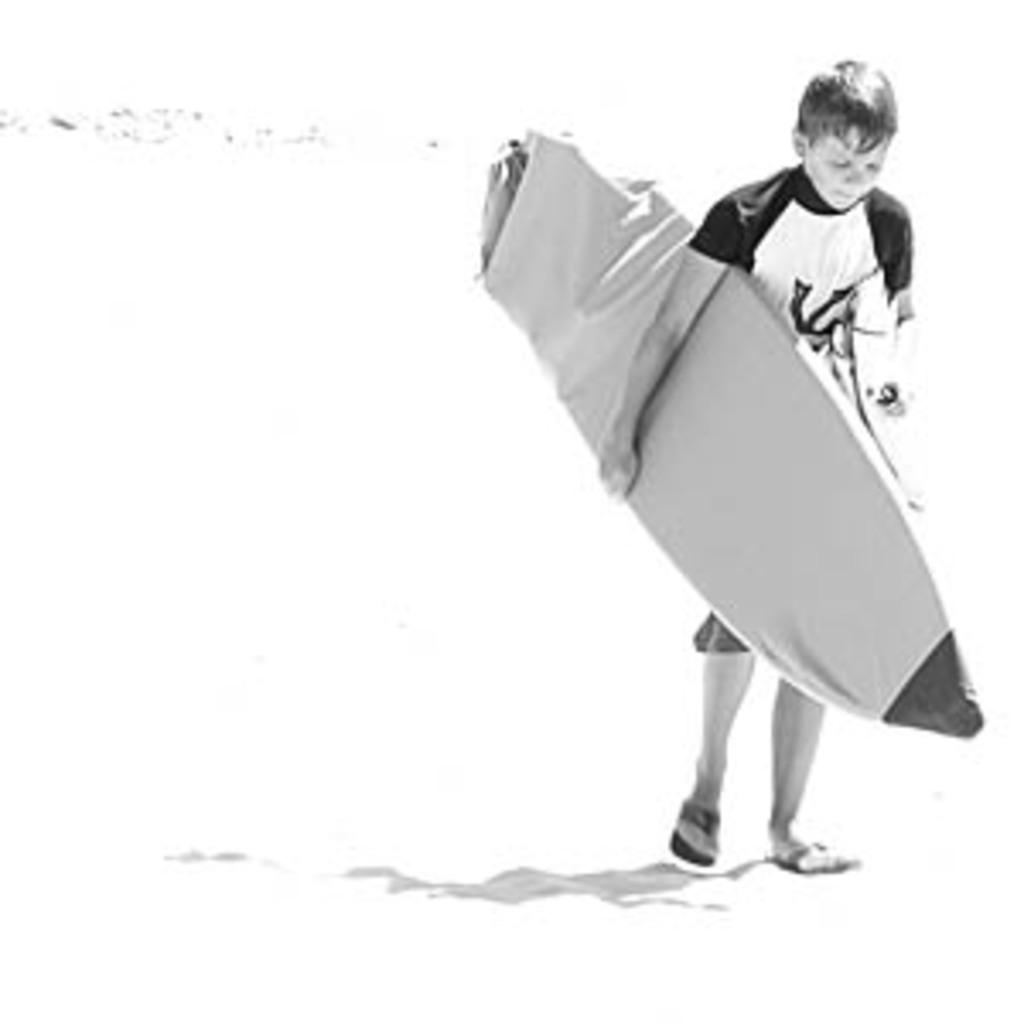Who is the main subject in the image? There is a boy in the image. What is the boy holding in the image? The boy is holding a surfboard. What is the price of the territory shown in the image? There is no territory present in the image, and therefore no price can be determined. 